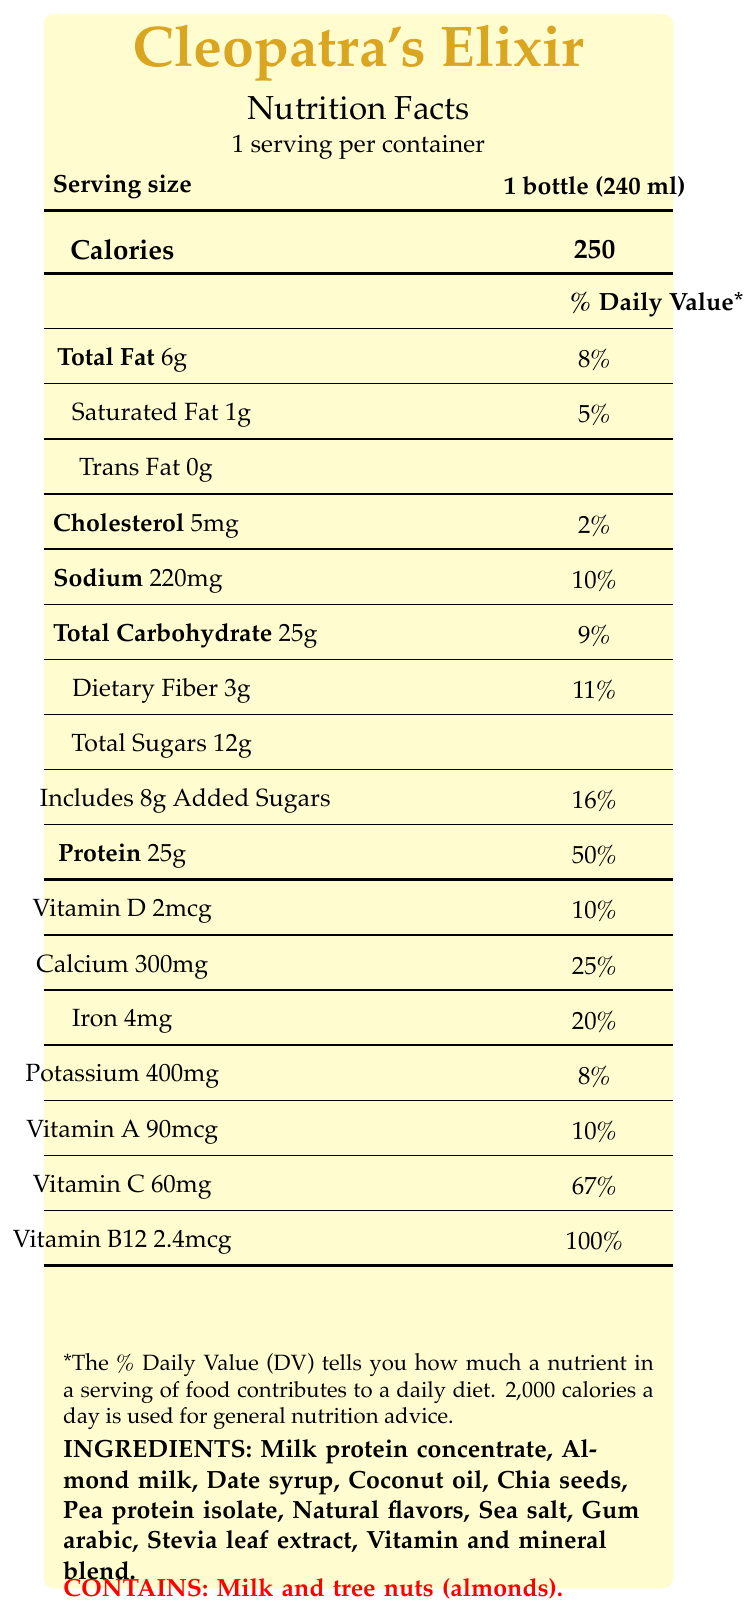what is the serving size? The serving size is specified clearly on the document as "1 bottle (240 ml)."
Answer: 1 bottle (240 ml) how many calories does one serving of Cleopatra's Elixir have? It is clearly stated in the document that one serving contains 250 calories.
Answer: 250 what is the amount of dietary fiber per serving? The document states that each serving contains 3 grams of dietary fiber.
Answer: 3g how much protein does one serving provide? The document indicates that there are 25 grams of protein per serving.
Answer: 25g which ingredient is listed first? The document lists ingredients in order of prominence, with "Milk protein concentrate" appearing first.
Answer: Milk protein concentrate how much sodium is in one serving? According to the document, one serving contains 220 mg of sodium.
Answer: 220mg what percentage of the daily value of iron does one serving contain? The document indicates one serving contains 20% of the daily value for iron.
Answer: 20% how many grams of total sugars are in one serving? A. 8g B. 12g C. 15g D. 5g The document states that there are 12 grams of total sugars per serving.
Answer: B. 12g what allergens are present in Cleopatra's Elixir? A. Soy and wheat B. Milk and tree nuts C. Peanuts and gluten D. Fish and shellfish The document specifies that Cleopatra's Elixir contains milk and tree nuts (almonds).
Answer: B. Milk and tree nuts which vitamin provides 100% of the daily value per serving? A. Vitamin A B. Vitamin C C. Vitamin B12 D. Vitamin D The document indicates that Vitamin B12 has a daily value percentage of 100%.
Answer: C. Vitamin B12 does Cleopatra's Elixir contain any trans fat? The document states that the amount of trans fat is 0g.
Answer: No summarize the main features of Cleopatra's Elixir. The document outlines the nutritional content and marketing appeal of Cleopatra's Elixir, emphasizing its protein content, vitamins and minerals, and specific benefits for actresses with demanding schedules.
Answer: Cleopatra's Elixir is a high-protein meal replacement shake designed for busy actresses, delivering 250 calories per 240 ml bottle. It contains 6g of total fat, 25g of protein, 3g of dietary fiber, and is rich in essential vitamins and minerals. It is marketed for sustained energy and beauty benefits. who is the manufacturer of Cleopatra's Elixir? The document specifies that Nile Nutrition Co., based in Alexandria, Egypt, is the manufacturer.
Answer: Nile Nutrition Co., Alexandria, Egypt how much calcium is in one serving? The document states one serving contains 300 mg of calcium.
Answer: 300mg what is the percentage daily value of Vitamin D in one serving? The document indicates that one serving contains 10% of the daily value for Vitamin D.
Answer: 10% how much-added sugar does one serving have? The document clearly states that there are 8 grams of added sugars per serving.
Answer: 8g what kind of flavors are used in Cleopatra's Elixir? The document lists "Natural flavors" among the ingredients used in Cleopatra's Elixir.
Answer: Natural flavors is there any information about where to buy Cleopatra's Elixir in the document? The document does not provide any information about where to purchase Cleopatra's Elixir.
Answer: No 